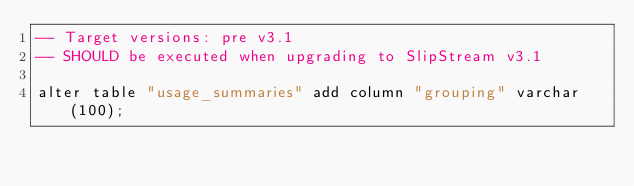<code> <loc_0><loc_0><loc_500><loc_500><_SQL_>-- Target versions: pre v3.1
-- SHOULD be executed when upgrading to SlipStream v3.1

alter table "usage_summaries" add column "grouping" varchar(100);
</code> 